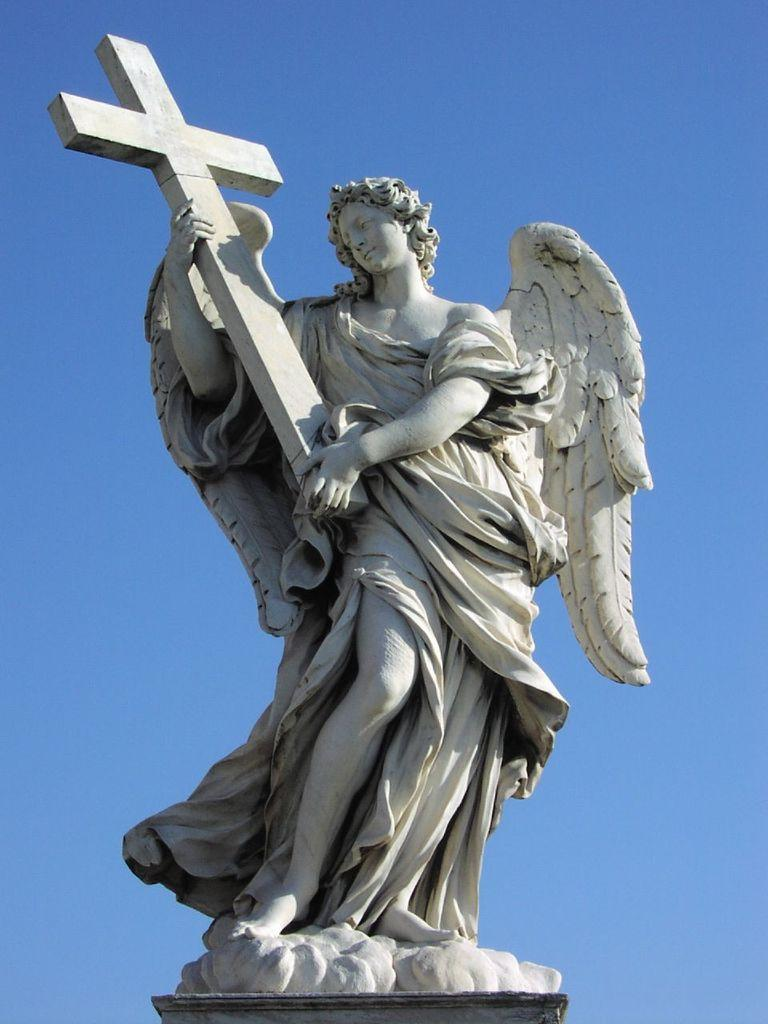What is the main subject of the image? There is a statue in the image. What is the color of the statue? The statue is white in color. What color is the sky in the image? The sky is blue in color. What type of zinc is used to create the statue in the image? There is no information about the material used to create the statue in the image. Additionally, zinc is not mentioned in the provided facts. 